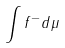<formula> <loc_0><loc_0><loc_500><loc_500>\int f ^ { - } d \mu</formula> 